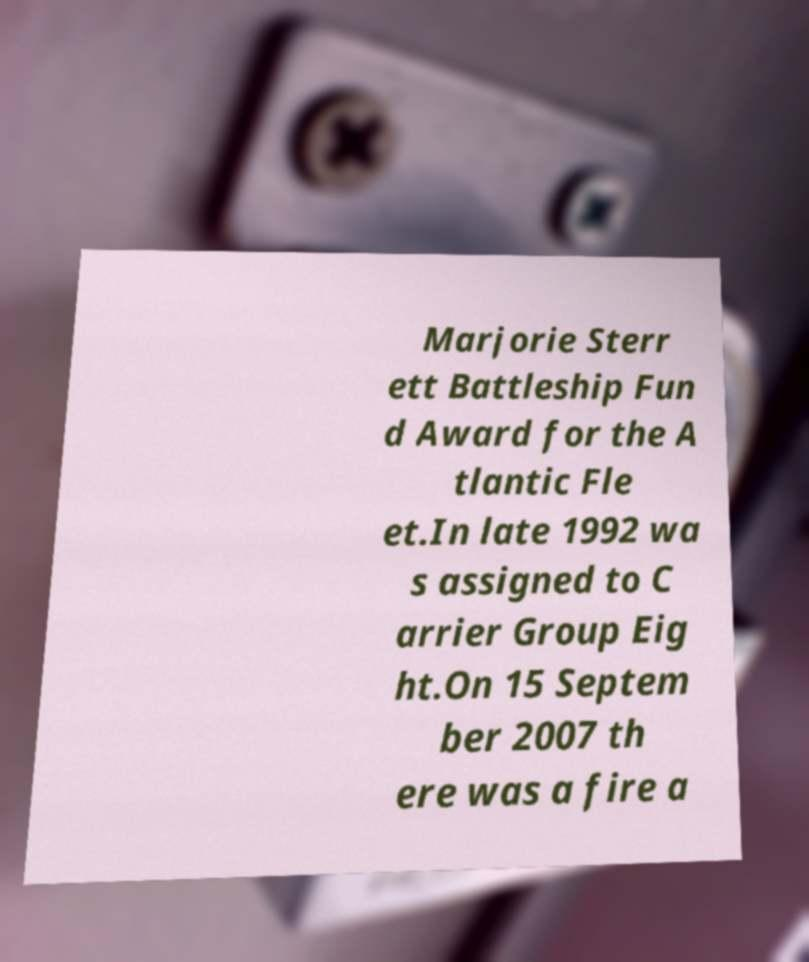I need the written content from this picture converted into text. Can you do that? Marjorie Sterr ett Battleship Fun d Award for the A tlantic Fle et.In late 1992 wa s assigned to C arrier Group Eig ht.On 15 Septem ber 2007 th ere was a fire a 